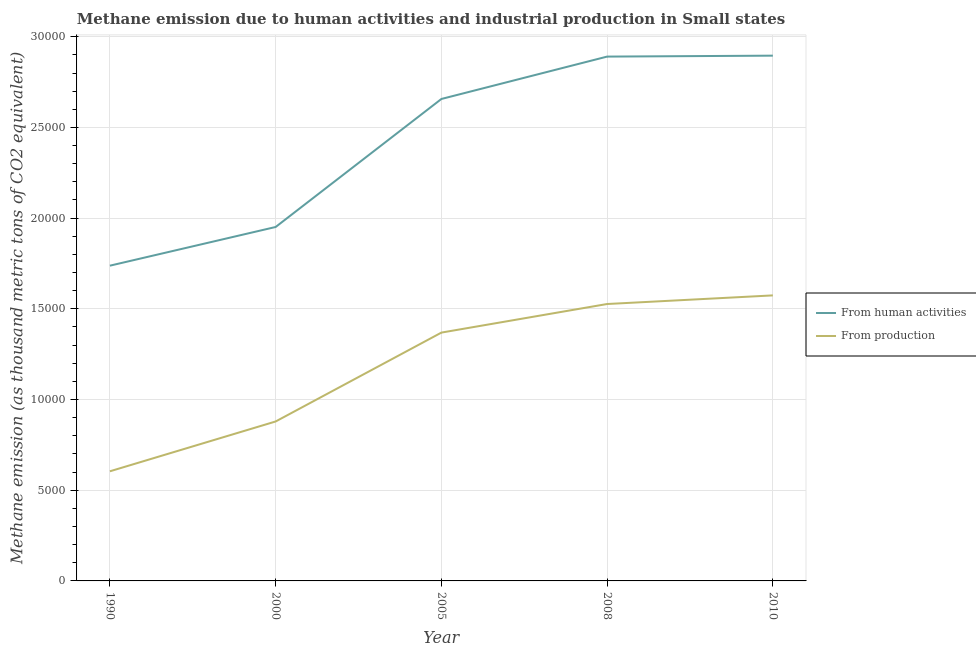What is the amount of emissions from human activities in 2008?
Provide a short and direct response. 2.89e+04. Across all years, what is the maximum amount of emissions generated from industries?
Your answer should be compact. 1.57e+04. Across all years, what is the minimum amount of emissions generated from industries?
Provide a short and direct response. 6043.6. What is the total amount of emissions from human activities in the graph?
Your response must be concise. 1.21e+05. What is the difference between the amount of emissions generated from industries in 2005 and that in 2010?
Provide a succinct answer. -2050.9. What is the difference between the amount of emissions generated from industries in 2000 and the amount of emissions from human activities in 2008?
Your response must be concise. -2.01e+04. What is the average amount of emissions from human activities per year?
Ensure brevity in your answer.  2.43e+04. In the year 2005, what is the difference between the amount of emissions from human activities and amount of emissions generated from industries?
Offer a very short reply. 1.29e+04. In how many years, is the amount of emissions from human activities greater than 17000 thousand metric tons?
Offer a very short reply. 5. What is the ratio of the amount of emissions generated from industries in 2008 to that in 2010?
Provide a short and direct response. 0.97. Is the difference between the amount of emissions from human activities in 2000 and 2008 greater than the difference between the amount of emissions generated from industries in 2000 and 2008?
Provide a succinct answer. No. What is the difference between the highest and the second highest amount of emissions generated from industries?
Provide a short and direct response. 474.8. What is the difference between the highest and the lowest amount of emissions from human activities?
Keep it short and to the point. 1.16e+04. In how many years, is the amount of emissions generated from industries greater than the average amount of emissions generated from industries taken over all years?
Your answer should be very brief. 3. Does the amount of emissions generated from industries monotonically increase over the years?
Ensure brevity in your answer.  Yes. Is the amount of emissions generated from industries strictly greater than the amount of emissions from human activities over the years?
Your answer should be very brief. No. Is the amount of emissions from human activities strictly less than the amount of emissions generated from industries over the years?
Ensure brevity in your answer.  No. How are the legend labels stacked?
Your response must be concise. Vertical. What is the title of the graph?
Make the answer very short. Methane emission due to human activities and industrial production in Small states. Does "Non-solid fuel" appear as one of the legend labels in the graph?
Your answer should be very brief. No. What is the label or title of the Y-axis?
Your answer should be very brief. Methane emission (as thousand metric tons of CO2 equivalent). What is the Methane emission (as thousand metric tons of CO2 equivalent) in From human activities in 1990?
Provide a succinct answer. 1.74e+04. What is the Methane emission (as thousand metric tons of CO2 equivalent) of From production in 1990?
Offer a terse response. 6043.6. What is the Methane emission (as thousand metric tons of CO2 equivalent) of From human activities in 2000?
Keep it short and to the point. 1.95e+04. What is the Methane emission (as thousand metric tons of CO2 equivalent) of From production in 2000?
Offer a very short reply. 8790. What is the Methane emission (as thousand metric tons of CO2 equivalent) in From human activities in 2005?
Your answer should be very brief. 2.66e+04. What is the Methane emission (as thousand metric tons of CO2 equivalent) of From production in 2005?
Offer a very short reply. 1.37e+04. What is the Methane emission (as thousand metric tons of CO2 equivalent) of From human activities in 2008?
Give a very brief answer. 2.89e+04. What is the Methane emission (as thousand metric tons of CO2 equivalent) of From production in 2008?
Give a very brief answer. 1.53e+04. What is the Methane emission (as thousand metric tons of CO2 equivalent) in From human activities in 2010?
Your answer should be compact. 2.90e+04. What is the Methane emission (as thousand metric tons of CO2 equivalent) of From production in 2010?
Provide a short and direct response. 1.57e+04. Across all years, what is the maximum Methane emission (as thousand metric tons of CO2 equivalent) of From human activities?
Keep it short and to the point. 2.90e+04. Across all years, what is the maximum Methane emission (as thousand metric tons of CO2 equivalent) of From production?
Make the answer very short. 1.57e+04. Across all years, what is the minimum Methane emission (as thousand metric tons of CO2 equivalent) of From human activities?
Make the answer very short. 1.74e+04. Across all years, what is the minimum Methane emission (as thousand metric tons of CO2 equivalent) in From production?
Offer a terse response. 6043.6. What is the total Methane emission (as thousand metric tons of CO2 equivalent) of From human activities in the graph?
Give a very brief answer. 1.21e+05. What is the total Methane emission (as thousand metric tons of CO2 equivalent) of From production in the graph?
Provide a short and direct response. 5.95e+04. What is the difference between the Methane emission (as thousand metric tons of CO2 equivalent) in From human activities in 1990 and that in 2000?
Provide a short and direct response. -2132.9. What is the difference between the Methane emission (as thousand metric tons of CO2 equivalent) in From production in 1990 and that in 2000?
Keep it short and to the point. -2746.4. What is the difference between the Methane emission (as thousand metric tons of CO2 equivalent) in From human activities in 1990 and that in 2005?
Your answer should be very brief. -9189.8. What is the difference between the Methane emission (as thousand metric tons of CO2 equivalent) in From production in 1990 and that in 2005?
Provide a short and direct response. -7645.8. What is the difference between the Methane emission (as thousand metric tons of CO2 equivalent) of From human activities in 1990 and that in 2008?
Give a very brief answer. -1.15e+04. What is the difference between the Methane emission (as thousand metric tons of CO2 equivalent) of From production in 1990 and that in 2008?
Make the answer very short. -9221.9. What is the difference between the Methane emission (as thousand metric tons of CO2 equivalent) in From human activities in 1990 and that in 2010?
Keep it short and to the point. -1.16e+04. What is the difference between the Methane emission (as thousand metric tons of CO2 equivalent) in From production in 1990 and that in 2010?
Ensure brevity in your answer.  -9696.7. What is the difference between the Methane emission (as thousand metric tons of CO2 equivalent) in From human activities in 2000 and that in 2005?
Your answer should be very brief. -7056.9. What is the difference between the Methane emission (as thousand metric tons of CO2 equivalent) of From production in 2000 and that in 2005?
Offer a very short reply. -4899.4. What is the difference between the Methane emission (as thousand metric tons of CO2 equivalent) in From human activities in 2000 and that in 2008?
Keep it short and to the point. -9393.1. What is the difference between the Methane emission (as thousand metric tons of CO2 equivalent) in From production in 2000 and that in 2008?
Your response must be concise. -6475.5. What is the difference between the Methane emission (as thousand metric tons of CO2 equivalent) of From human activities in 2000 and that in 2010?
Provide a short and direct response. -9444.8. What is the difference between the Methane emission (as thousand metric tons of CO2 equivalent) in From production in 2000 and that in 2010?
Your answer should be very brief. -6950.3. What is the difference between the Methane emission (as thousand metric tons of CO2 equivalent) of From human activities in 2005 and that in 2008?
Offer a very short reply. -2336.2. What is the difference between the Methane emission (as thousand metric tons of CO2 equivalent) of From production in 2005 and that in 2008?
Offer a very short reply. -1576.1. What is the difference between the Methane emission (as thousand metric tons of CO2 equivalent) of From human activities in 2005 and that in 2010?
Offer a terse response. -2387.9. What is the difference between the Methane emission (as thousand metric tons of CO2 equivalent) in From production in 2005 and that in 2010?
Make the answer very short. -2050.9. What is the difference between the Methane emission (as thousand metric tons of CO2 equivalent) of From human activities in 2008 and that in 2010?
Provide a succinct answer. -51.7. What is the difference between the Methane emission (as thousand metric tons of CO2 equivalent) in From production in 2008 and that in 2010?
Your answer should be very brief. -474.8. What is the difference between the Methane emission (as thousand metric tons of CO2 equivalent) of From human activities in 1990 and the Methane emission (as thousand metric tons of CO2 equivalent) of From production in 2000?
Ensure brevity in your answer.  8588.7. What is the difference between the Methane emission (as thousand metric tons of CO2 equivalent) of From human activities in 1990 and the Methane emission (as thousand metric tons of CO2 equivalent) of From production in 2005?
Your answer should be very brief. 3689.3. What is the difference between the Methane emission (as thousand metric tons of CO2 equivalent) in From human activities in 1990 and the Methane emission (as thousand metric tons of CO2 equivalent) in From production in 2008?
Your answer should be compact. 2113.2. What is the difference between the Methane emission (as thousand metric tons of CO2 equivalent) in From human activities in 1990 and the Methane emission (as thousand metric tons of CO2 equivalent) in From production in 2010?
Your response must be concise. 1638.4. What is the difference between the Methane emission (as thousand metric tons of CO2 equivalent) in From human activities in 2000 and the Methane emission (as thousand metric tons of CO2 equivalent) in From production in 2005?
Make the answer very short. 5822.2. What is the difference between the Methane emission (as thousand metric tons of CO2 equivalent) in From human activities in 2000 and the Methane emission (as thousand metric tons of CO2 equivalent) in From production in 2008?
Your answer should be compact. 4246.1. What is the difference between the Methane emission (as thousand metric tons of CO2 equivalent) in From human activities in 2000 and the Methane emission (as thousand metric tons of CO2 equivalent) in From production in 2010?
Provide a short and direct response. 3771.3. What is the difference between the Methane emission (as thousand metric tons of CO2 equivalent) in From human activities in 2005 and the Methane emission (as thousand metric tons of CO2 equivalent) in From production in 2008?
Keep it short and to the point. 1.13e+04. What is the difference between the Methane emission (as thousand metric tons of CO2 equivalent) of From human activities in 2005 and the Methane emission (as thousand metric tons of CO2 equivalent) of From production in 2010?
Offer a terse response. 1.08e+04. What is the difference between the Methane emission (as thousand metric tons of CO2 equivalent) in From human activities in 2008 and the Methane emission (as thousand metric tons of CO2 equivalent) in From production in 2010?
Provide a succinct answer. 1.32e+04. What is the average Methane emission (as thousand metric tons of CO2 equivalent) in From human activities per year?
Give a very brief answer. 2.43e+04. What is the average Methane emission (as thousand metric tons of CO2 equivalent) of From production per year?
Offer a terse response. 1.19e+04. In the year 1990, what is the difference between the Methane emission (as thousand metric tons of CO2 equivalent) in From human activities and Methane emission (as thousand metric tons of CO2 equivalent) in From production?
Provide a succinct answer. 1.13e+04. In the year 2000, what is the difference between the Methane emission (as thousand metric tons of CO2 equivalent) in From human activities and Methane emission (as thousand metric tons of CO2 equivalent) in From production?
Your answer should be compact. 1.07e+04. In the year 2005, what is the difference between the Methane emission (as thousand metric tons of CO2 equivalent) in From human activities and Methane emission (as thousand metric tons of CO2 equivalent) in From production?
Give a very brief answer. 1.29e+04. In the year 2008, what is the difference between the Methane emission (as thousand metric tons of CO2 equivalent) in From human activities and Methane emission (as thousand metric tons of CO2 equivalent) in From production?
Make the answer very short. 1.36e+04. In the year 2010, what is the difference between the Methane emission (as thousand metric tons of CO2 equivalent) in From human activities and Methane emission (as thousand metric tons of CO2 equivalent) in From production?
Offer a very short reply. 1.32e+04. What is the ratio of the Methane emission (as thousand metric tons of CO2 equivalent) of From human activities in 1990 to that in 2000?
Offer a very short reply. 0.89. What is the ratio of the Methane emission (as thousand metric tons of CO2 equivalent) in From production in 1990 to that in 2000?
Offer a very short reply. 0.69. What is the ratio of the Methane emission (as thousand metric tons of CO2 equivalent) of From human activities in 1990 to that in 2005?
Give a very brief answer. 0.65. What is the ratio of the Methane emission (as thousand metric tons of CO2 equivalent) of From production in 1990 to that in 2005?
Your response must be concise. 0.44. What is the ratio of the Methane emission (as thousand metric tons of CO2 equivalent) in From human activities in 1990 to that in 2008?
Ensure brevity in your answer.  0.6. What is the ratio of the Methane emission (as thousand metric tons of CO2 equivalent) in From production in 1990 to that in 2008?
Your answer should be compact. 0.4. What is the ratio of the Methane emission (as thousand metric tons of CO2 equivalent) in From human activities in 1990 to that in 2010?
Provide a succinct answer. 0.6. What is the ratio of the Methane emission (as thousand metric tons of CO2 equivalent) in From production in 1990 to that in 2010?
Your answer should be compact. 0.38. What is the ratio of the Methane emission (as thousand metric tons of CO2 equivalent) in From human activities in 2000 to that in 2005?
Keep it short and to the point. 0.73. What is the ratio of the Methane emission (as thousand metric tons of CO2 equivalent) in From production in 2000 to that in 2005?
Your answer should be compact. 0.64. What is the ratio of the Methane emission (as thousand metric tons of CO2 equivalent) in From human activities in 2000 to that in 2008?
Your answer should be compact. 0.68. What is the ratio of the Methane emission (as thousand metric tons of CO2 equivalent) of From production in 2000 to that in 2008?
Make the answer very short. 0.58. What is the ratio of the Methane emission (as thousand metric tons of CO2 equivalent) in From human activities in 2000 to that in 2010?
Give a very brief answer. 0.67. What is the ratio of the Methane emission (as thousand metric tons of CO2 equivalent) of From production in 2000 to that in 2010?
Keep it short and to the point. 0.56. What is the ratio of the Methane emission (as thousand metric tons of CO2 equivalent) of From human activities in 2005 to that in 2008?
Your response must be concise. 0.92. What is the ratio of the Methane emission (as thousand metric tons of CO2 equivalent) in From production in 2005 to that in 2008?
Offer a terse response. 0.9. What is the ratio of the Methane emission (as thousand metric tons of CO2 equivalent) in From human activities in 2005 to that in 2010?
Offer a terse response. 0.92. What is the ratio of the Methane emission (as thousand metric tons of CO2 equivalent) of From production in 2005 to that in 2010?
Your answer should be compact. 0.87. What is the ratio of the Methane emission (as thousand metric tons of CO2 equivalent) of From production in 2008 to that in 2010?
Your answer should be very brief. 0.97. What is the difference between the highest and the second highest Methane emission (as thousand metric tons of CO2 equivalent) in From human activities?
Provide a short and direct response. 51.7. What is the difference between the highest and the second highest Methane emission (as thousand metric tons of CO2 equivalent) of From production?
Make the answer very short. 474.8. What is the difference between the highest and the lowest Methane emission (as thousand metric tons of CO2 equivalent) in From human activities?
Ensure brevity in your answer.  1.16e+04. What is the difference between the highest and the lowest Methane emission (as thousand metric tons of CO2 equivalent) of From production?
Your answer should be compact. 9696.7. 